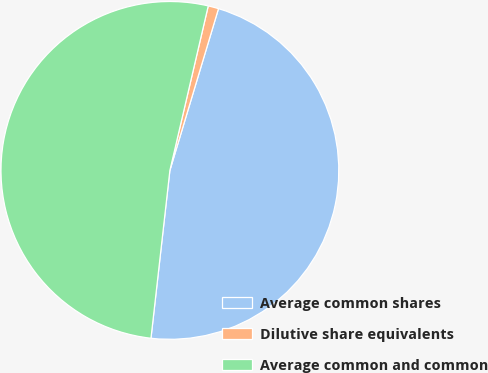Convert chart to OTSL. <chart><loc_0><loc_0><loc_500><loc_500><pie_chart><fcel>Average common shares<fcel>Dilutive share equivalents<fcel>Average common and common<nl><fcel>47.14%<fcel>1.0%<fcel>51.86%<nl></chart> 